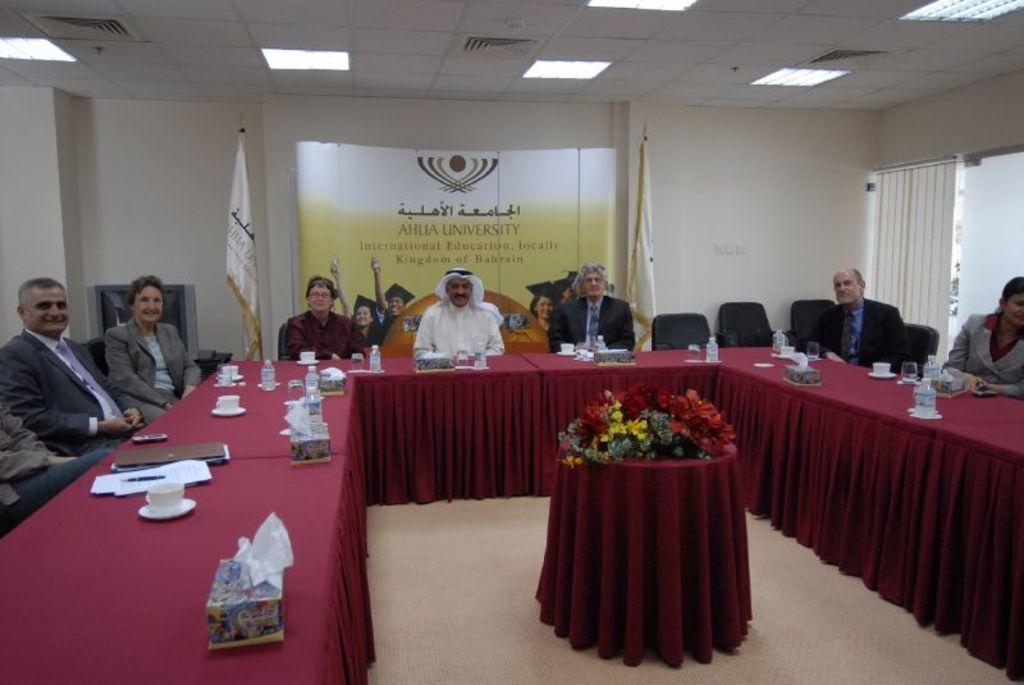How would you summarize this image in a sentence or two? In this picture I can see group of people sitting on the chairs. I can see cups with saucers, papers, water bottles, tissues boxes, flowers and some other objects on the tables. I can see flags, board, lights, television and some other objects. 